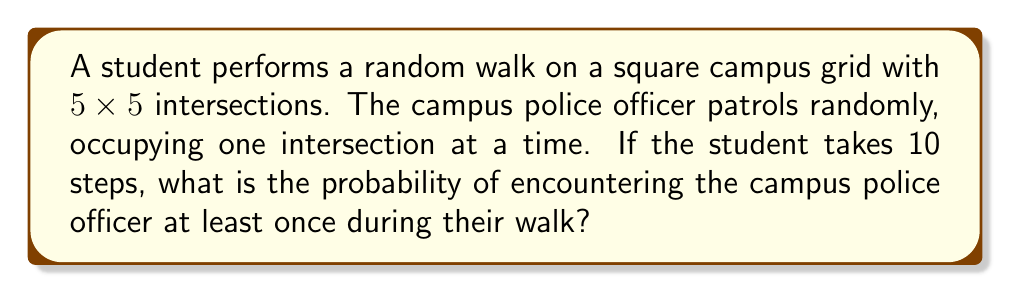What is the answer to this math problem? Let's approach this step-by-step:

1) First, we need to calculate the probability of not encountering the officer in a single step:
   - Total intersections = $5 \times 5 = 25$
   - Probability of not encountering = $\frac{24}{25}$

2) For the entire walk of 10 steps, the probability of not encountering the officer at all is:
   $$ P(\text{no encounter}) = \left(\frac{24}{25}\right)^{10} $$

3) Therefore, the probability of encountering the officer at least once is:
   $$ P(\text{at least one encounter}) = 1 - P(\text{no encounter}) $$
   $$ = 1 - \left(\frac{24}{25}\right)^{10} $$

4) Let's calculate this:
   $$ = 1 - \left(0.96\right)^{10} $$
   $$ = 1 - 0.6695789785 $$
   $$ = 0.3304210215 $$

5) This can be rounded to approximately 0.3304 or 33.04%.
Answer: $1 - \left(\frac{24}{25}\right)^{10} \approx 0.3304$ 